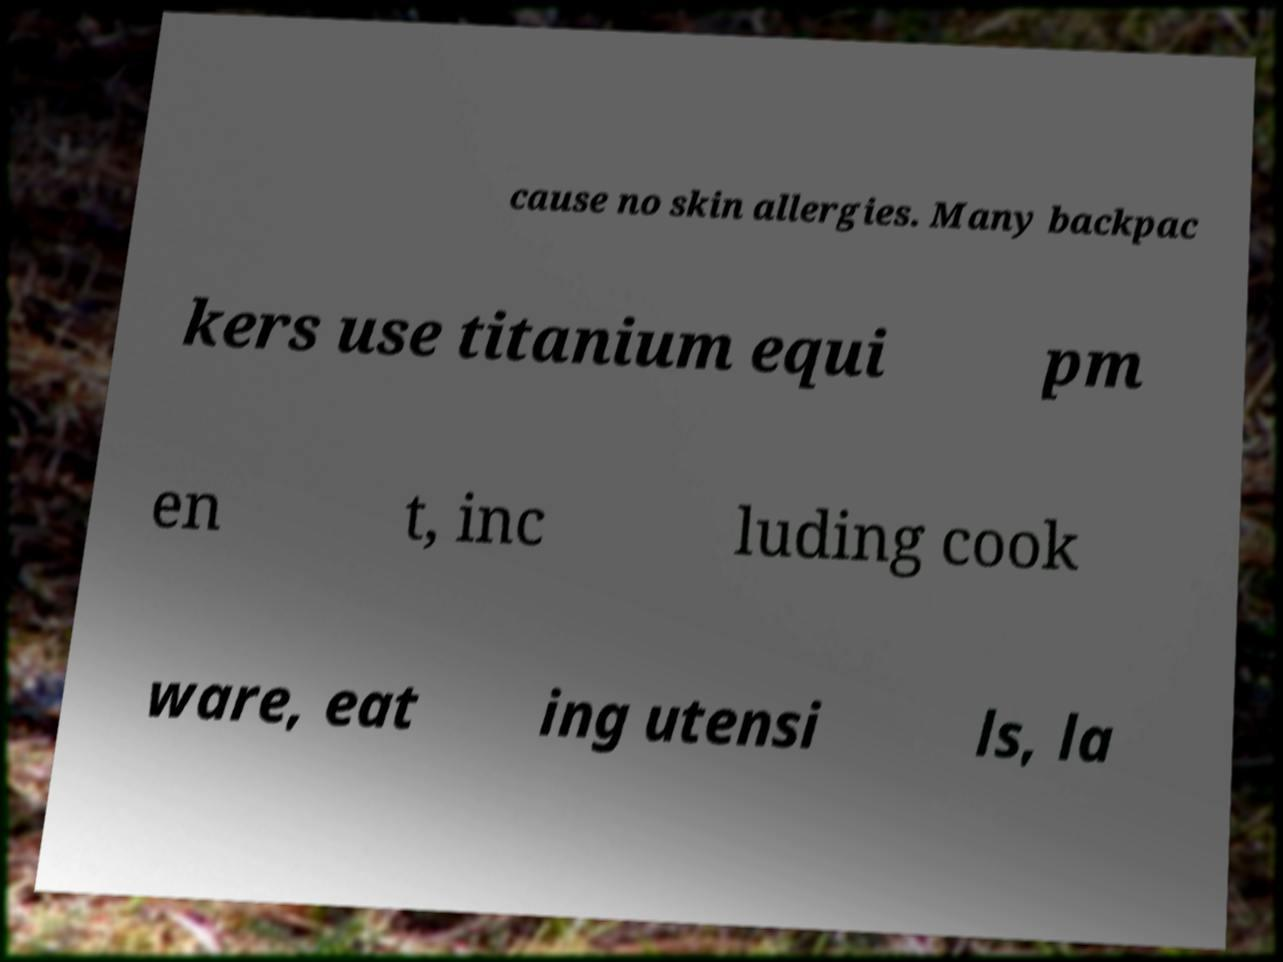I need the written content from this picture converted into text. Can you do that? cause no skin allergies. Many backpac kers use titanium equi pm en t, inc luding cook ware, eat ing utensi ls, la 